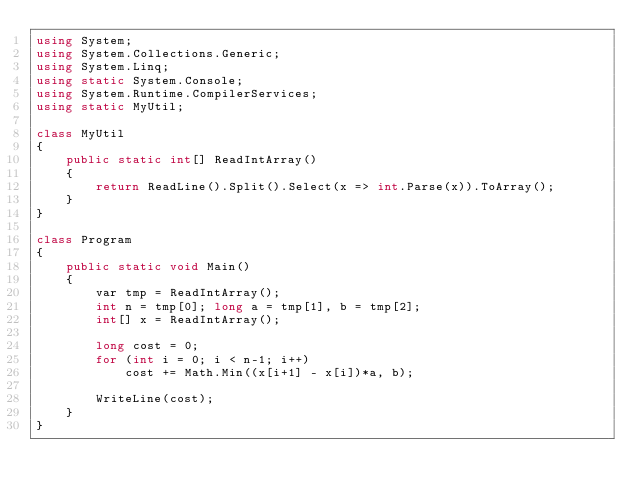<code> <loc_0><loc_0><loc_500><loc_500><_C#_>using System;
using System.Collections.Generic;
using System.Linq;
using static System.Console;
using System.Runtime.CompilerServices;
using static MyUtil;

class MyUtil
{
    public static int[] ReadIntArray()
    {
        return ReadLine().Split().Select(x => int.Parse(x)).ToArray();
    }
}

class Program
{
    public static void Main()
    {
        var tmp = ReadIntArray();
        int n = tmp[0]; long a = tmp[1], b = tmp[2];
        int[] x = ReadIntArray();

        long cost = 0;
        for (int i = 0; i < n-1; i++)
            cost += Math.Min((x[i+1] - x[i])*a, b);

        WriteLine(cost);
    }
}
</code> 